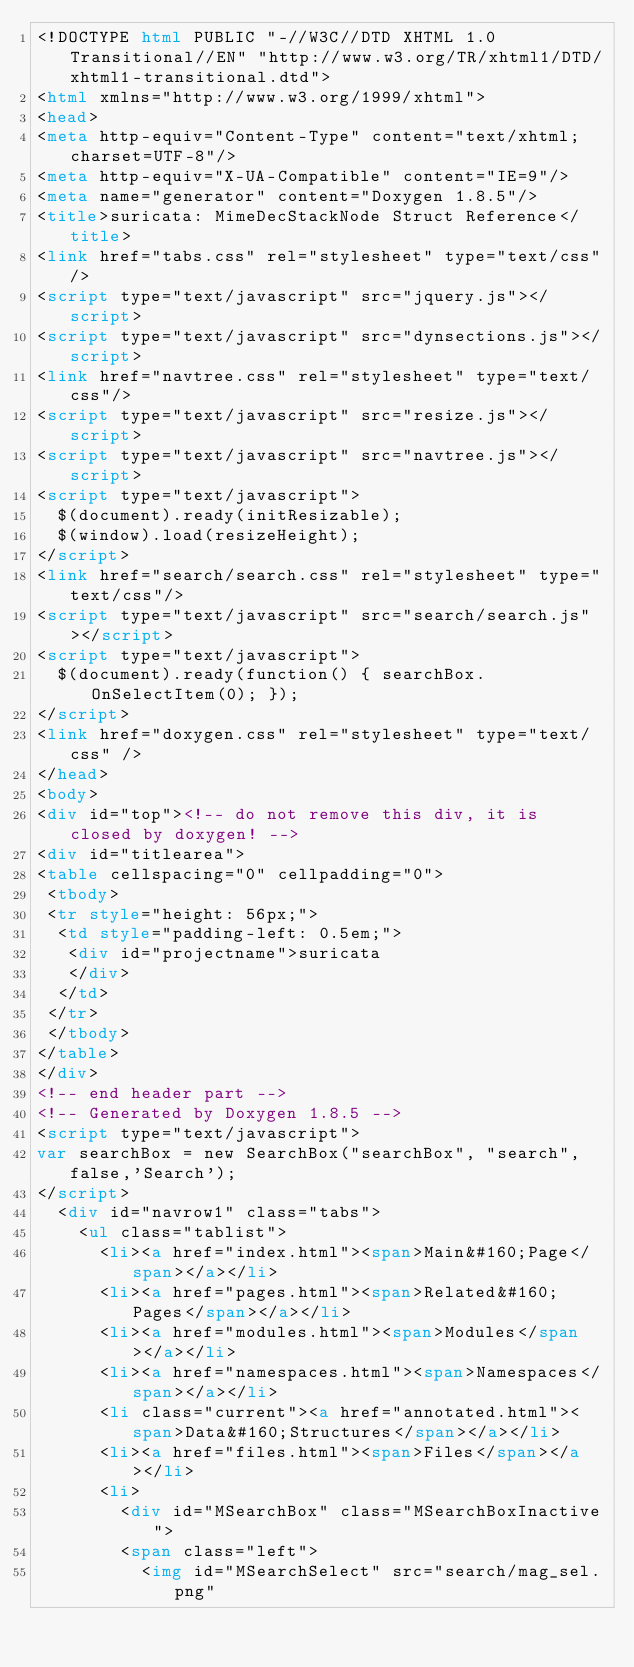Convert code to text. <code><loc_0><loc_0><loc_500><loc_500><_HTML_><!DOCTYPE html PUBLIC "-//W3C//DTD XHTML 1.0 Transitional//EN" "http://www.w3.org/TR/xhtml1/DTD/xhtml1-transitional.dtd">
<html xmlns="http://www.w3.org/1999/xhtml">
<head>
<meta http-equiv="Content-Type" content="text/xhtml;charset=UTF-8"/>
<meta http-equiv="X-UA-Compatible" content="IE=9"/>
<meta name="generator" content="Doxygen 1.8.5"/>
<title>suricata: MimeDecStackNode Struct Reference</title>
<link href="tabs.css" rel="stylesheet" type="text/css"/>
<script type="text/javascript" src="jquery.js"></script>
<script type="text/javascript" src="dynsections.js"></script>
<link href="navtree.css" rel="stylesheet" type="text/css"/>
<script type="text/javascript" src="resize.js"></script>
<script type="text/javascript" src="navtree.js"></script>
<script type="text/javascript">
  $(document).ready(initResizable);
  $(window).load(resizeHeight);
</script>
<link href="search/search.css" rel="stylesheet" type="text/css"/>
<script type="text/javascript" src="search/search.js"></script>
<script type="text/javascript">
  $(document).ready(function() { searchBox.OnSelectItem(0); });
</script>
<link href="doxygen.css" rel="stylesheet" type="text/css" />
</head>
<body>
<div id="top"><!-- do not remove this div, it is closed by doxygen! -->
<div id="titlearea">
<table cellspacing="0" cellpadding="0">
 <tbody>
 <tr style="height: 56px;">
  <td style="padding-left: 0.5em;">
   <div id="projectname">suricata
   </div>
  </td>
 </tr>
 </tbody>
</table>
</div>
<!-- end header part -->
<!-- Generated by Doxygen 1.8.5 -->
<script type="text/javascript">
var searchBox = new SearchBox("searchBox", "search",false,'Search');
</script>
  <div id="navrow1" class="tabs">
    <ul class="tablist">
      <li><a href="index.html"><span>Main&#160;Page</span></a></li>
      <li><a href="pages.html"><span>Related&#160;Pages</span></a></li>
      <li><a href="modules.html"><span>Modules</span></a></li>
      <li><a href="namespaces.html"><span>Namespaces</span></a></li>
      <li class="current"><a href="annotated.html"><span>Data&#160;Structures</span></a></li>
      <li><a href="files.html"><span>Files</span></a></li>
      <li>
        <div id="MSearchBox" class="MSearchBoxInactive">
        <span class="left">
          <img id="MSearchSelect" src="search/mag_sel.png"</code> 